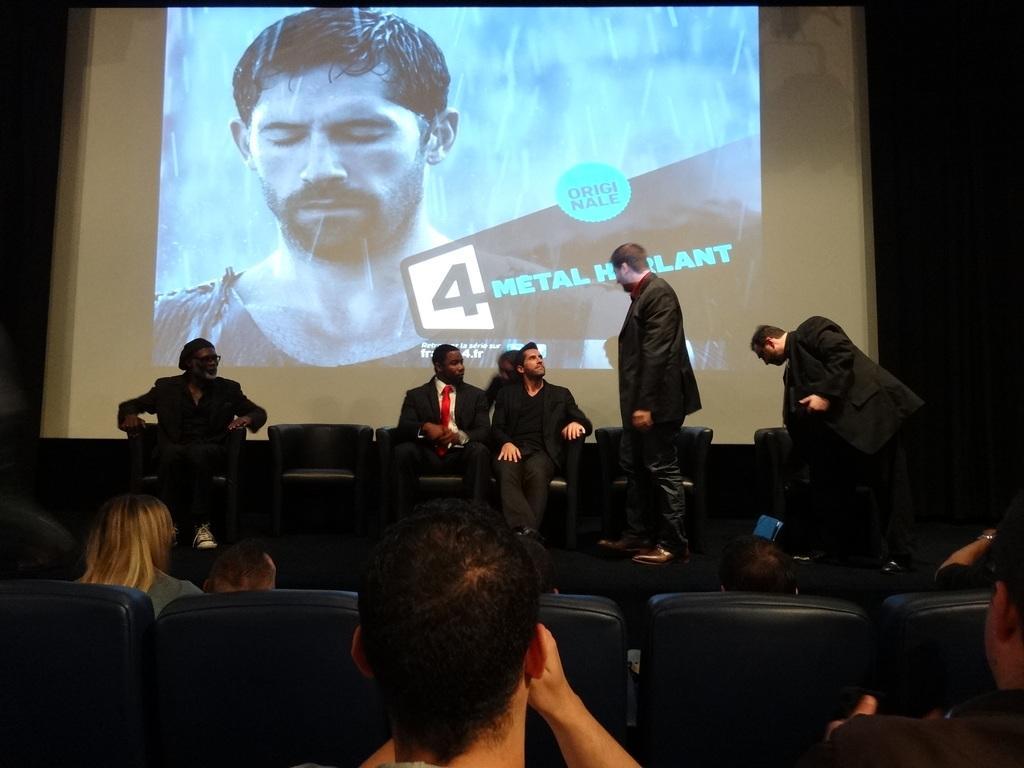Please provide a concise description of this image. In this image I can see few people sitting on chairs and few people standing. In the background I can see a huge screen in which I can see a person and few water drops. 